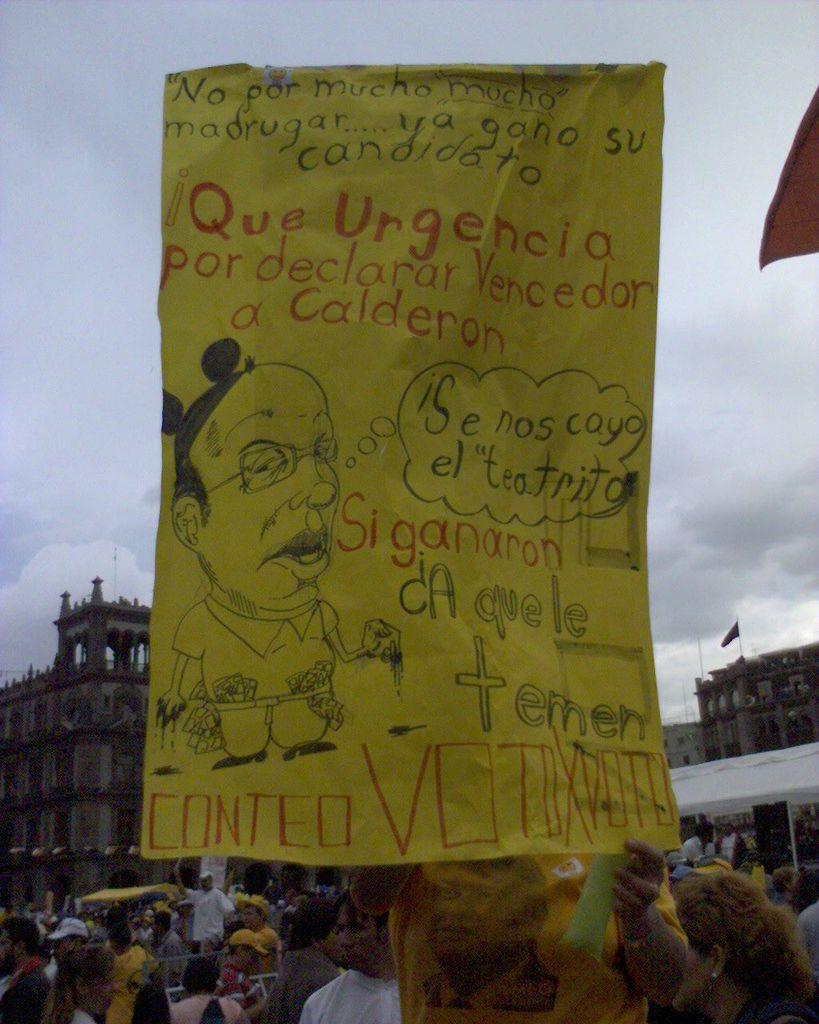What is the person in the foreground of the image doing? The person is holding a banner in the image. What can be seen in the background of the image? There are people standing on the road, flags, buildings, and the sky visible in the background. How many elements can be identified in the background of the image? There are four elements present in the background: people, flags, buildings, and the sky. How many cats are visible on the ship in the image? There is no ship or cats present in the image. What is the profit margin of the event depicted in the image? There is no information about an event or profit margin in the image. 